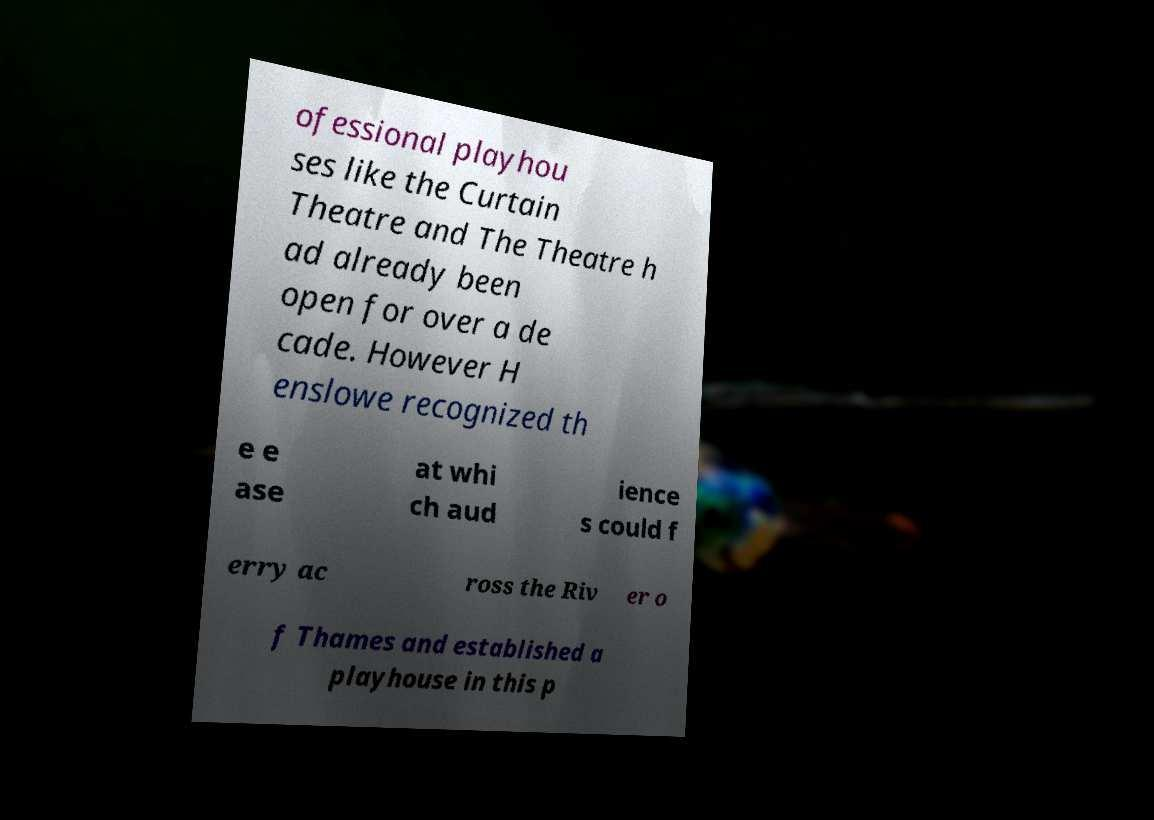Could you assist in decoding the text presented in this image and type it out clearly? ofessional playhou ses like the Curtain Theatre and The Theatre h ad already been open for over a de cade. However H enslowe recognized th e e ase at whi ch aud ience s could f erry ac ross the Riv er o f Thames and established a playhouse in this p 